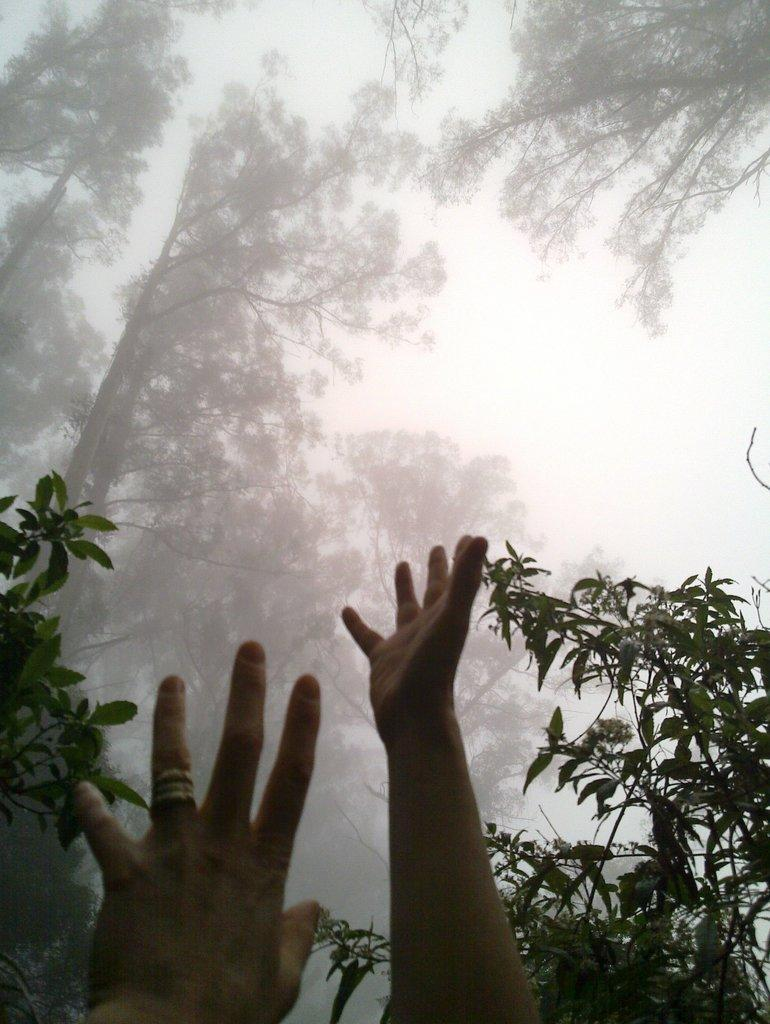What body parts are visible in the image? There are human hands in the image. What type of natural environment can be seen in the image? There are trees visible in the image. What atmospheric condition is present at the top of the image? There is fog at the top of the image. What is visible in the background of the image? The sky is visible in the image. What type of fruit is being peeled by the eye with teeth in the image? There is no fruit, eye, or teeth present in the image. 